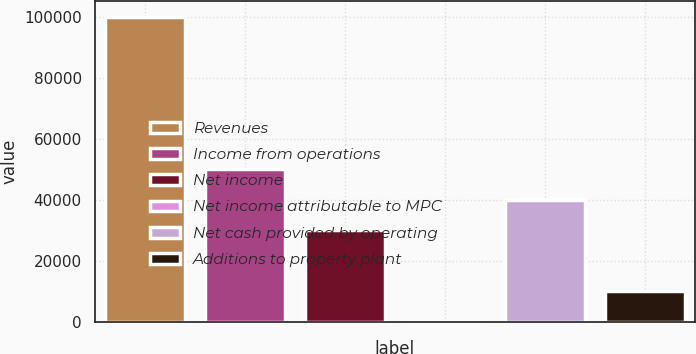Convert chart. <chart><loc_0><loc_0><loc_500><loc_500><bar_chart><fcel>Revenues<fcel>Income from operations<fcel>Net income<fcel>Net income attributable to MPC<fcel>Net cash provided by operating<fcel>Additions to property plant<nl><fcel>100160<fcel>50083.3<fcel>30052.7<fcel>6.69<fcel>40068<fcel>10022<nl></chart> 